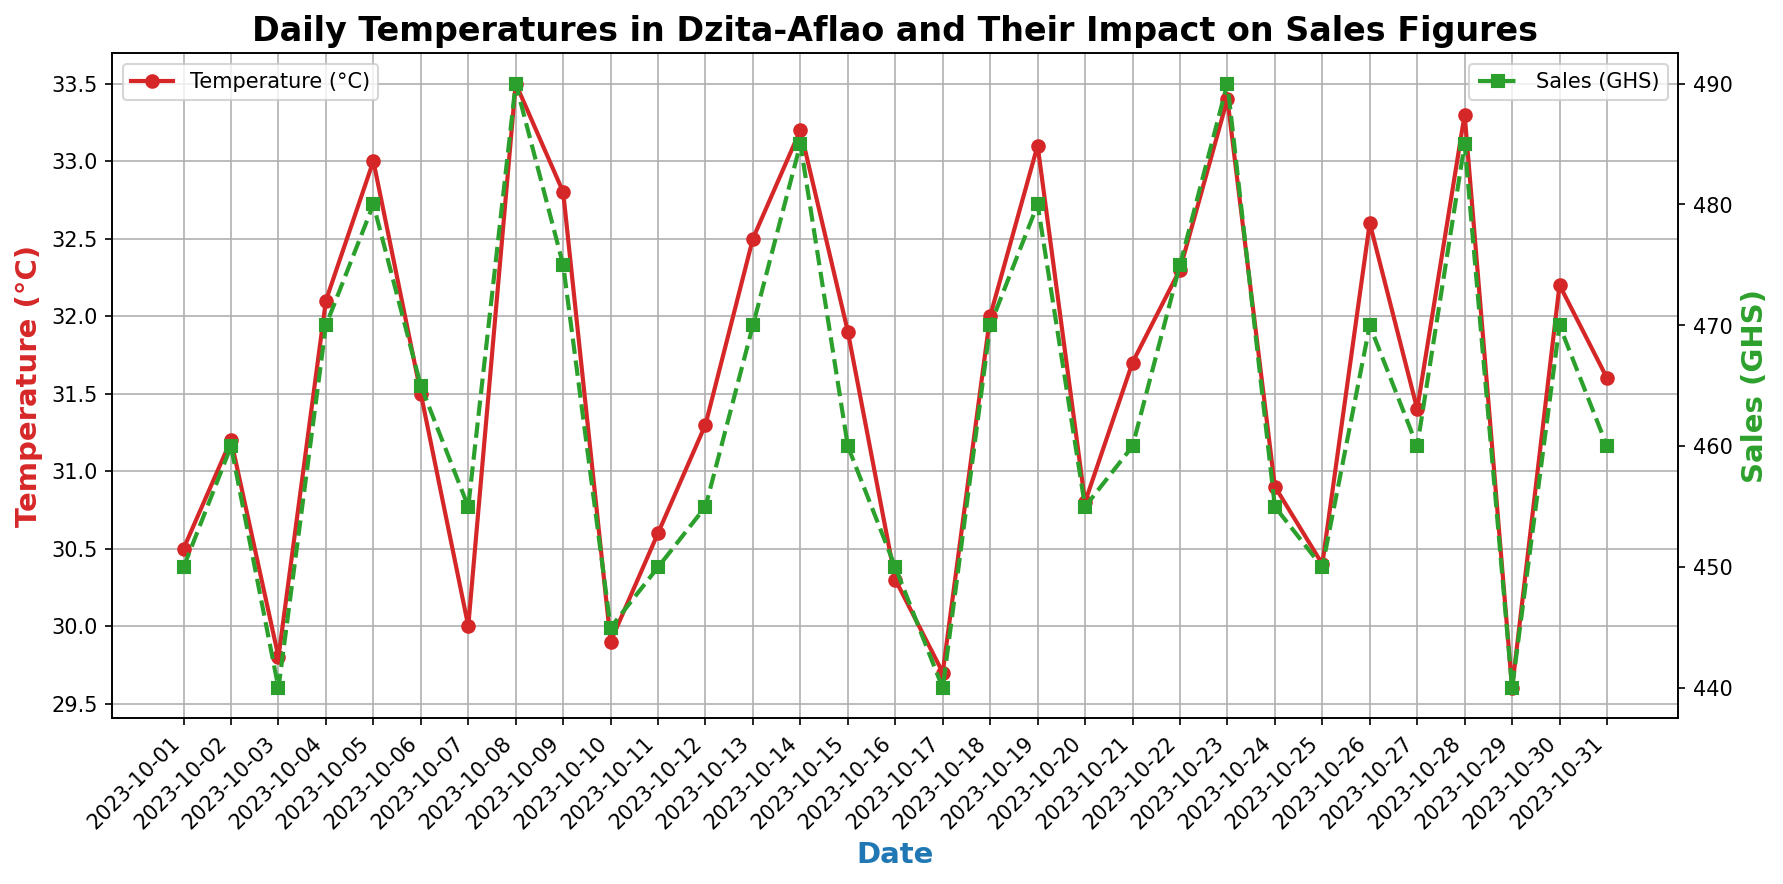Which date had the highest sales? Look for the peak point on the sales (GHS) line, which is in green. The highest value is 490 GHS. Identify the corresponding date on the x-axis.
Answer: October 8 and October 23 Is there a date where temperatures were below 30°C and what was the corresponding sales figure? Look for points on the red temperature line below 30°C and then identify the corresponding green sales line value.
Answer: Yes, October 17, 440 GHS On which date did the temperature reach its highest point, and what was the sales figure on that day? Identify the highest point on the red temperature line. Look at the corresponding date and then check the sales line on the green plot for the same date.
Answer: October 8, 490 GHS Which date had the lowest sales and what was the temperature on that day? Find the lowest point on the green sales line, then check the corresponding date and look at the red temperature line for the same date.
Answer: Multiple dates: October 3 and October 17, 29.8°C and 29.7°C How many days had temperatures higher than 32.5°C, and what were the sales figures on those days? Identify all points on the temperature line above 32.5°C, then map those dates to the sales figures from the corresponding points.
Answer: 8 days (October 5, October 8, October 13, October 14, October 19, October 23, October 28, October 30), sales figures: 480, 490, 470, 485, 480, 490, 485, 470 GHS By how much did the sales increase from October 1 to October 5? Find the sales value on October 1 and October 5, then calculate the difference.
Answer: Increased by 30 GHS On which date did both temperature and sales experience a simultaneous peak, and what were those values? Identify the peak values for both temperature and sales, then check if they occur on the same date.
Answer: October 8, Temperature: 33.5°C, Sales: 490 GHS Compare the sales figures on October 10 and October 20. Which date had higher sales and by how much? Note the sales figures on both dates and calculate the difference.
Answer: October 20 by 10 GHS Is there a general trend in sales when the temperature is above 31°C compared to when it's below 31°C? Segment the data into temperatures above and below 31°C and analyze the sales figures in both segments to see the trend.
Answer: Generally higher above 31°C What's the average temperature over the given period? Sum all the temperature values and divide by the number of days to get the average.
Answer: 31.4°C 